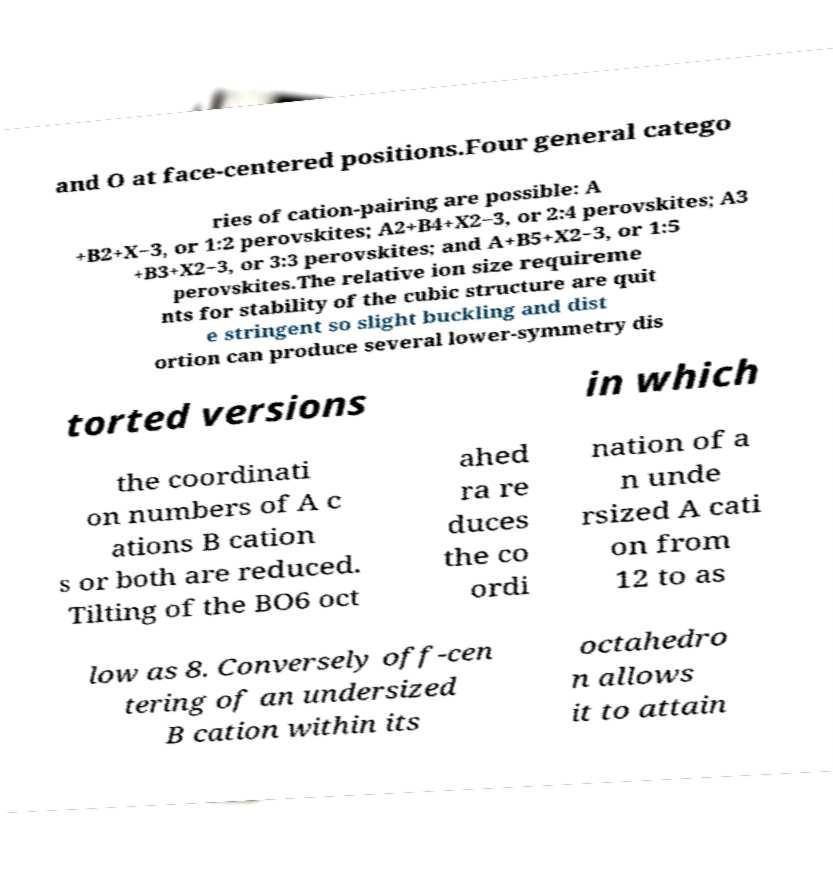Please identify and transcribe the text found in this image. and O at face-centered positions.Four general catego ries of cation-pairing are possible: A +B2+X−3, or 1:2 perovskites; A2+B4+X2−3, or 2:4 perovskites; A3 +B3+X2−3, or 3:3 perovskites; and A+B5+X2−3, or 1:5 perovskites.The relative ion size requireme nts for stability of the cubic structure are quit e stringent so slight buckling and dist ortion can produce several lower-symmetry dis torted versions in which the coordinati on numbers of A c ations B cation s or both are reduced. Tilting of the BO6 oct ahed ra re duces the co ordi nation of a n unde rsized A cati on from 12 to as low as 8. Conversely off-cen tering of an undersized B cation within its octahedro n allows it to attain 